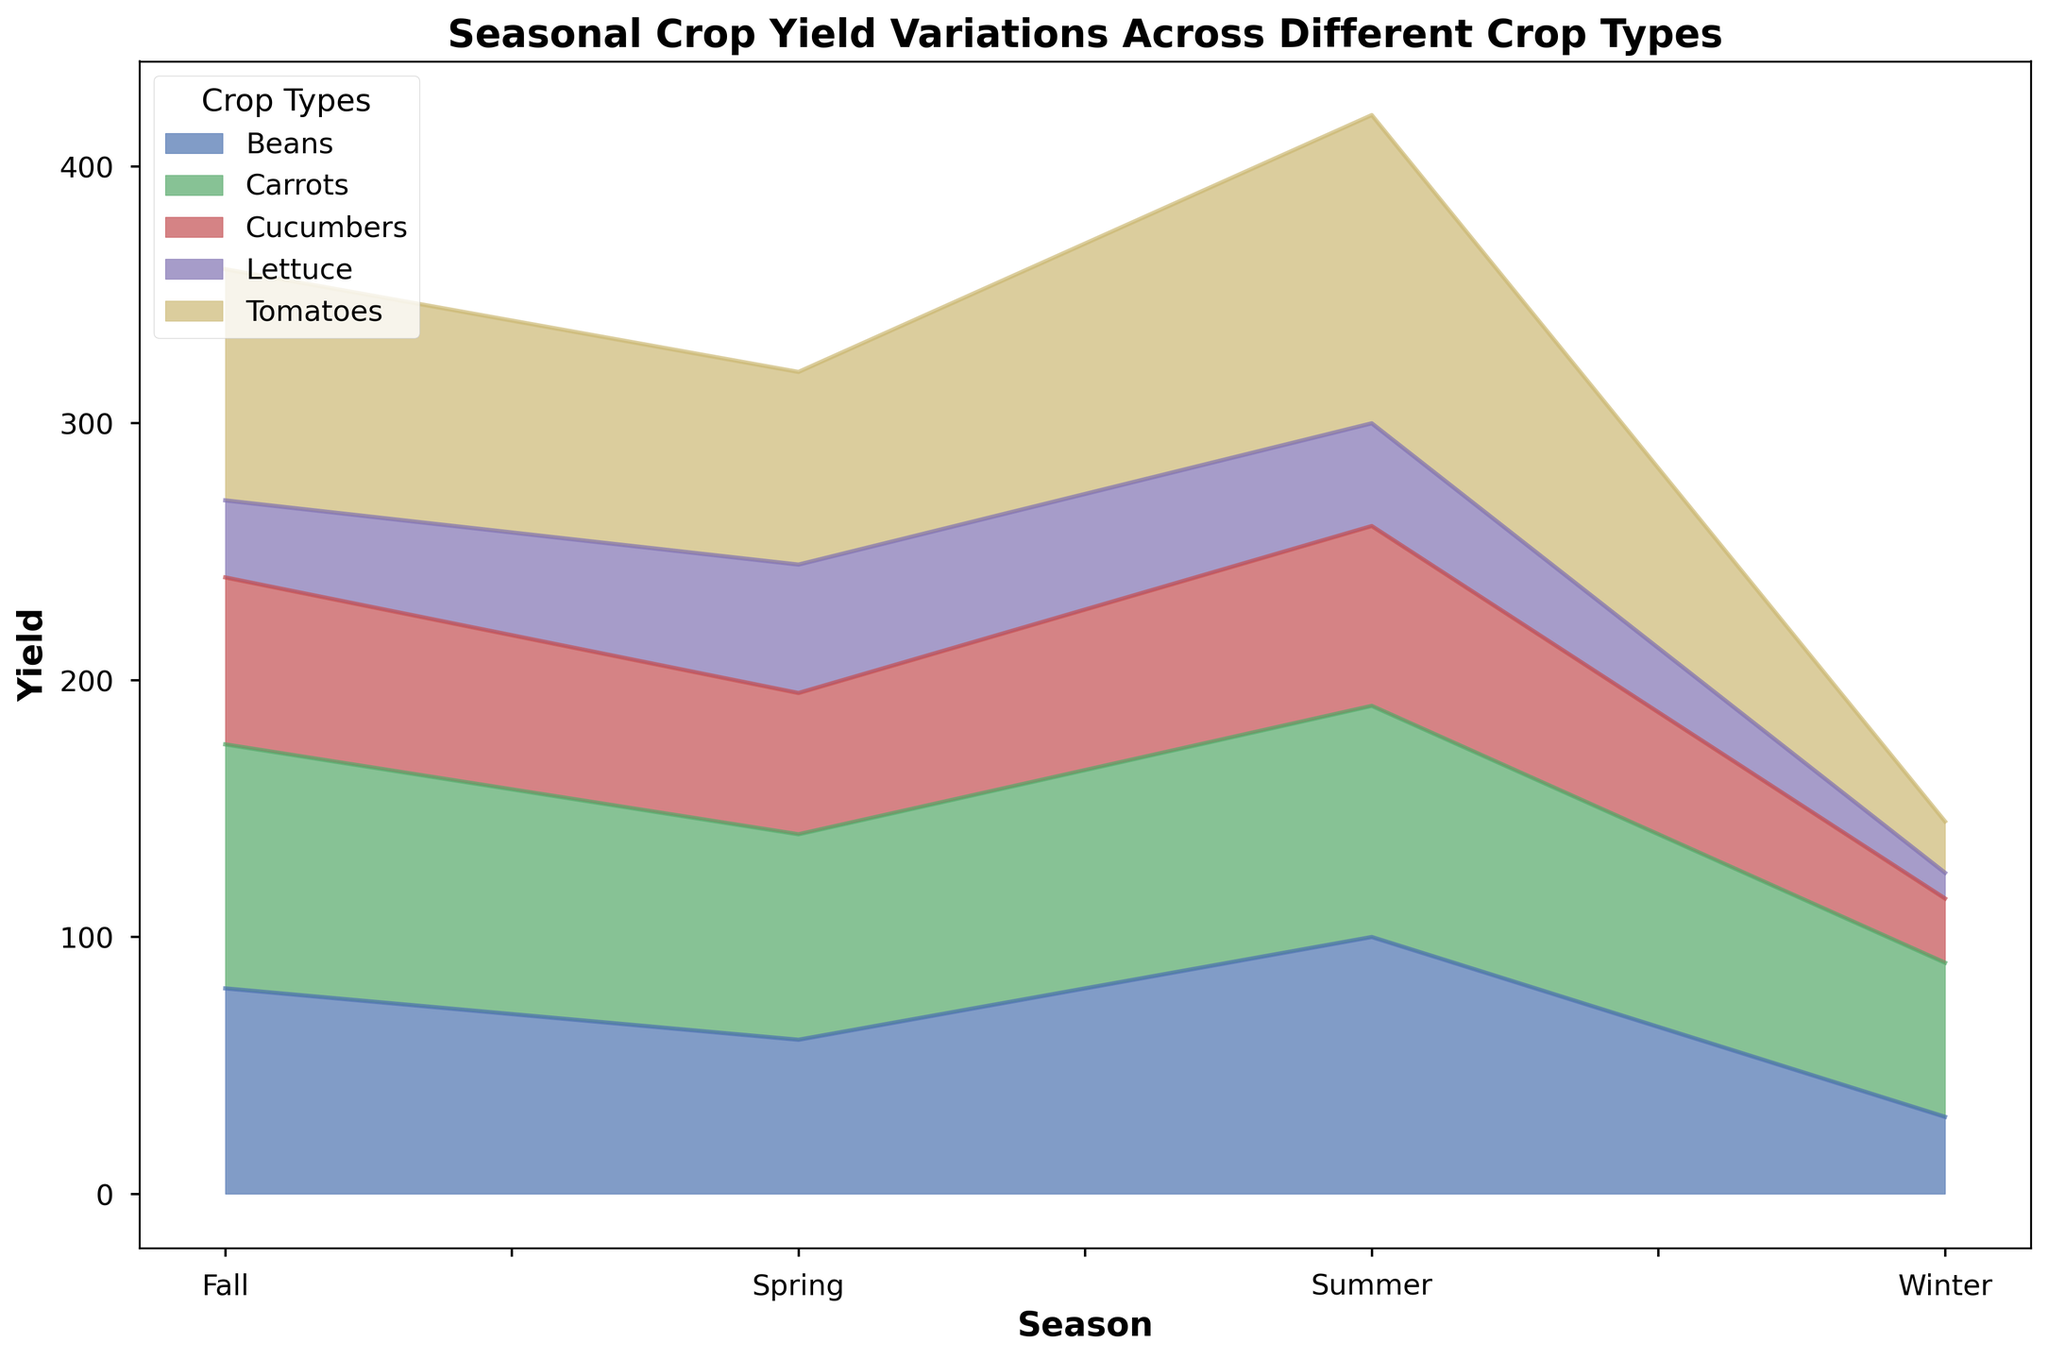What season has the highest yield for tomatoes? There are four seasons represented in the chart. By looking at the height of the area corresponding to tomatoes for each season, it is clear that the yield is highest during the summer.
Answer: Summer How does the yield of beans in winter compare to the yield of cucumbers in winter? The yield of beans in winter and cucumbers in winter can be compared by looking at the height of the corresponding areas for the winter season. Beans have a higher yield than cucumbers in winter.
Answer: Beans have a higher yield Which crop has the smallest yield in fall? By examining the area representing crop yields for the fall season, lettuce has the smallest area, indicating the lowest yield.
Answer: Lettuce What is the difference in the yield of tomatoes between summer and spring? The yield of tomatoes in summer can be compared to the yield in spring by noting their respective areas' heights. The yield in summer is 120 and in spring is 75, resulting in a difference of 45.
Answer: 45 What season has the lowest total yield for all crops combined? To find the season with the lowest total yield, compare the sum of the areas for each crop in each season. The winter season has the smallest combined area for all crops.
Answer: Winter On average, do most crops see a higher yield in summer compared to spring? By visually inspecting the areas covered by all crops in summer and comparing them with those in the spring, it appears that most crops (such as tomatoes, beans, and carrots) have a higher yield in summer compared to spring.
Answer: Yes Which crops have a yield that decreases from summer to fall? To identify the crops with decreasing yield from summer to fall, observe the areas for these two seasons. Both tomatoes and cucumbers decline in yield from summer to fall.
Answer: Tomatoes and Cucumbers Is there a crop type that maintains a steadily increasing yield from winter to fall? Review each crop’s yield across the seasons to determine if any show a consistent increase. Carrots have a steady increase in yield from winter to fall.
Answer: Carrots 